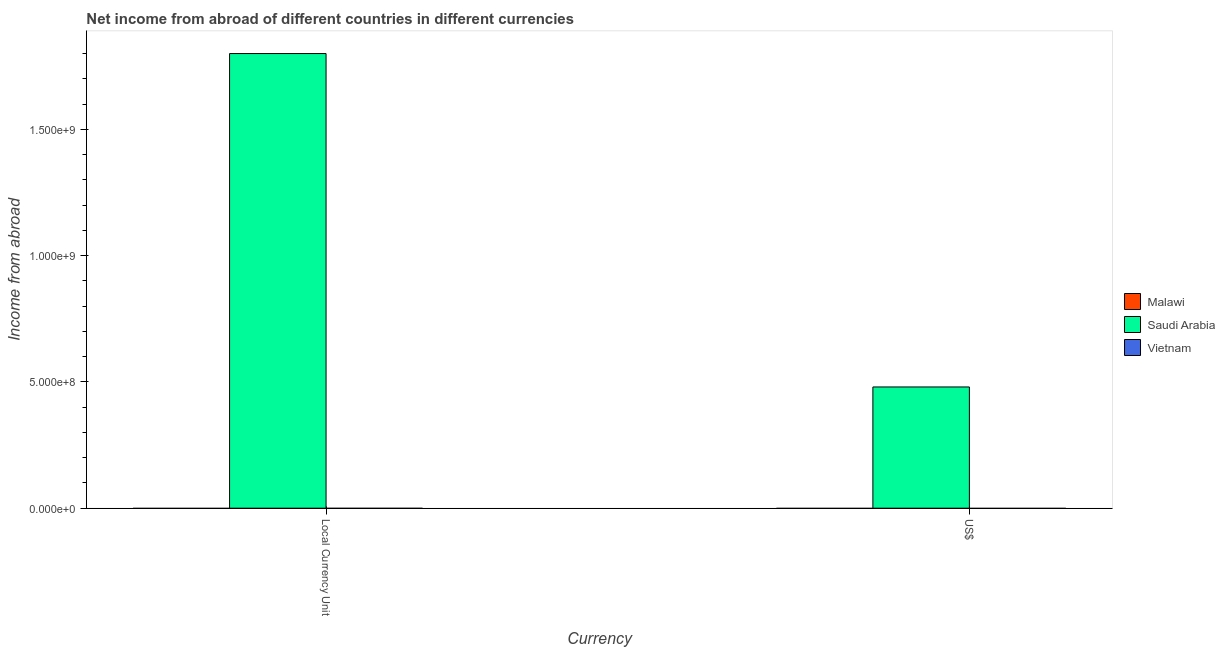How many different coloured bars are there?
Give a very brief answer. 1. Are the number of bars per tick equal to the number of legend labels?
Give a very brief answer. No. What is the label of the 1st group of bars from the left?
Provide a short and direct response. Local Currency Unit. What is the income from abroad in constant 2005 us$ in Vietnam?
Your response must be concise. 0. Across all countries, what is the maximum income from abroad in constant 2005 us$?
Give a very brief answer. 1.80e+09. Across all countries, what is the minimum income from abroad in constant 2005 us$?
Make the answer very short. 0. In which country was the income from abroad in us$ maximum?
Give a very brief answer. Saudi Arabia. What is the total income from abroad in constant 2005 us$ in the graph?
Ensure brevity in your answer.  1.80e+09. What is the difference between the income from abroad in constant 2005 us$ in Saudi Arabia and the income from abroad in us$ in Malawi?
Make the answer very short. 1.80e+09. What is the average income from abroad in constant 2005 us$ per country?
Ensure brevity in your answer.  6.00e+08. What is the difference between the income from abroad in constant 2005 us$ and income from abroad in us$ in Saudi Arabia?
Your response must be concise. 1.32e+09. Are all the bars in the graph horizontal?
Offer a very short reply. No. What is the difference between two consecutive major ticks on the Y-axis?
Provide a short and direct response. 5.00e+08. Are the values on the major ticks of Y-axis written in scientific E-notation?
Your answer should be very brief. Yes. What is the title of the graph?
Offer a terse response. Net income from abroad of different countries in different currencies. What is the label or title of the X-axis?
Offer a terse response. Currency. What is the label or title of the Y-axis?
Keep it short and to the point. Income from abroad. What is the Income from abroad of Saudi Arabia in Local Currency Unit?
Your response must be concise. 1.80e+09. What is the Income from abroad of Vietnam in Local Currency Unit?
Give a very brief answer. 0. What is the Income from abroad of Malawi in US$?
Give a very brief answer. 0. What is the Income from abroad of Saudi Arabia in US$?
Offer a terse response. 4.80e+08. Across all Currency, what is the maximum Income from abroad in Saudi Arabia?
Make the answer very short. 1.80e+09. Across all Currency, what is the minimum Income from abroad of Saudi Arabia?
Your answer should be compact. 4.80e+08. What is the total Income from abroad in Malawi in the graph?
Offer a terse response. 0. What is the total Income from abroad of Saudi Arabia in the graph?
Ensure brevity in your answer.  2.28e+09. What is the difference between the Income from abroad in Saudi Arabia in Local Currency Unit and that in US$?
Provide a short and direct response. 1.32e+09. What is the average Income from abroad in Saudi Arabia per Currency?
Your answer should be compact. 1.14e+09. What is the average Income from abroad in Vietnam per Currency?
Your answer should be compact. 0. What is the ratio of the Income from abroad of Saudi Arabia in Local Currency Unit to that in US$?
Ensure brevity in your answer.  3.75. What is the difference between the highest and the second highest Income from abroad in Saudi Arabia?
Give a very brief answer. 1.32e+09. What is the difference between the highest and the lowest Income from abroad of Saudi Arabia?
Provide a succinct answer. 1.32e+09. 